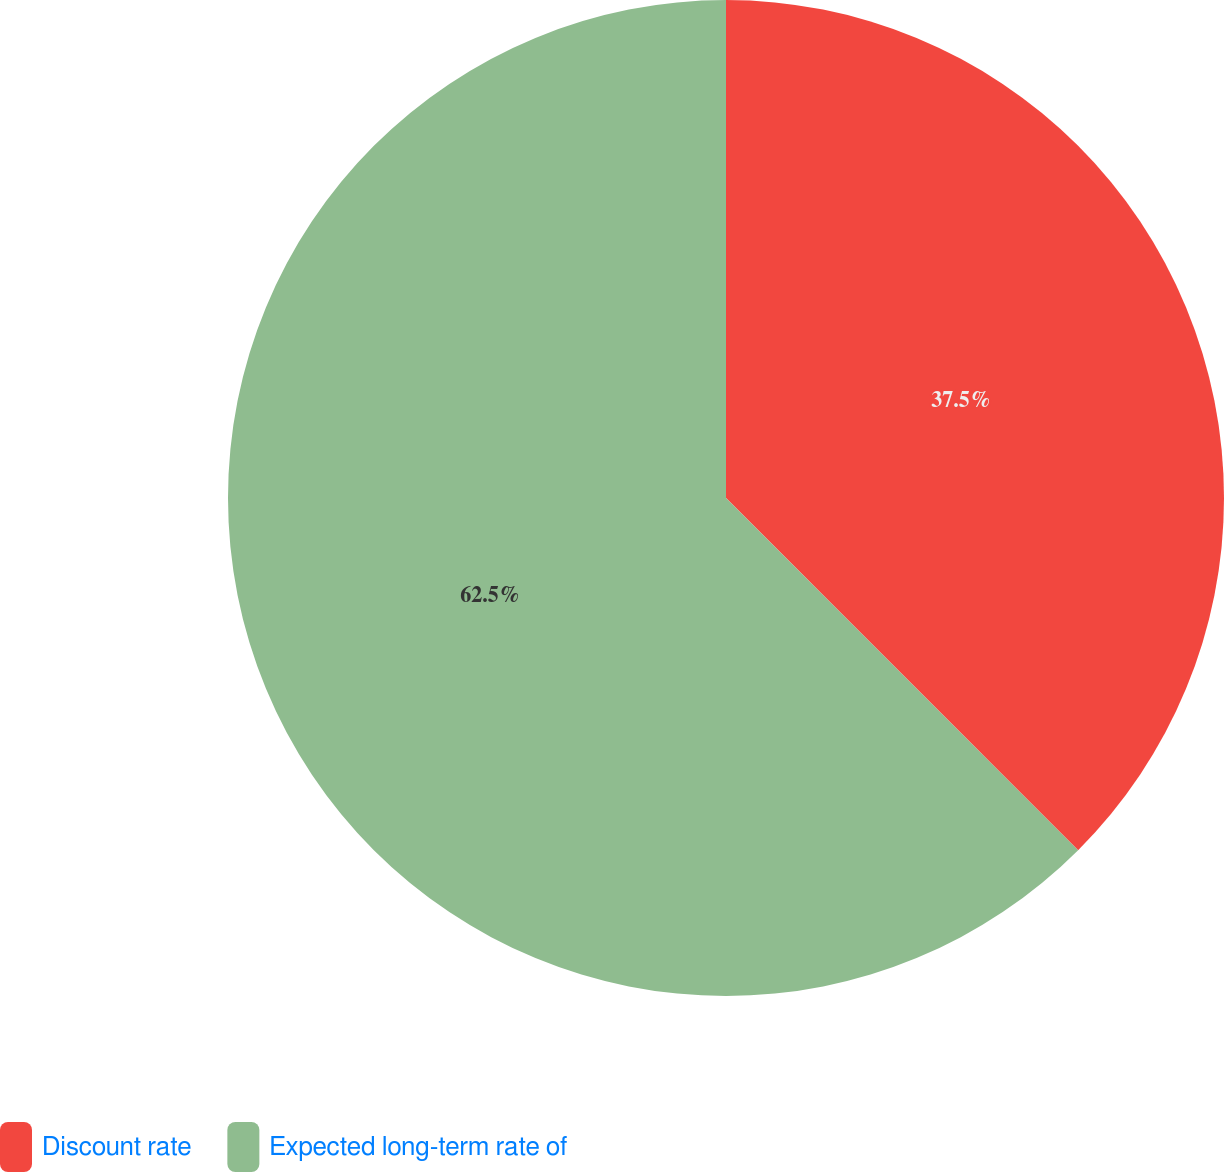<chart> <loc_0><loc_0><loc_500><loc_500><pie_chart><fcel>Discount rate<fcel>Expected long-term rate of<nl><fcel>37.5%<fcel>62.5%<nl></chart> 